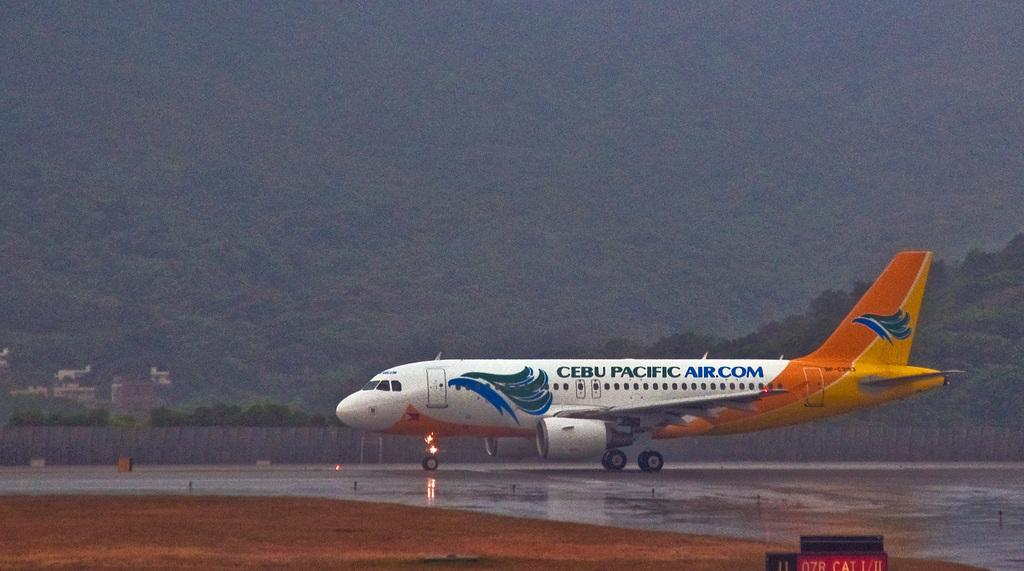Provide a one-sentence caption for the provided image. CEBU Pacific airplane that is sitting on the runway at an airport on an overcast day. 